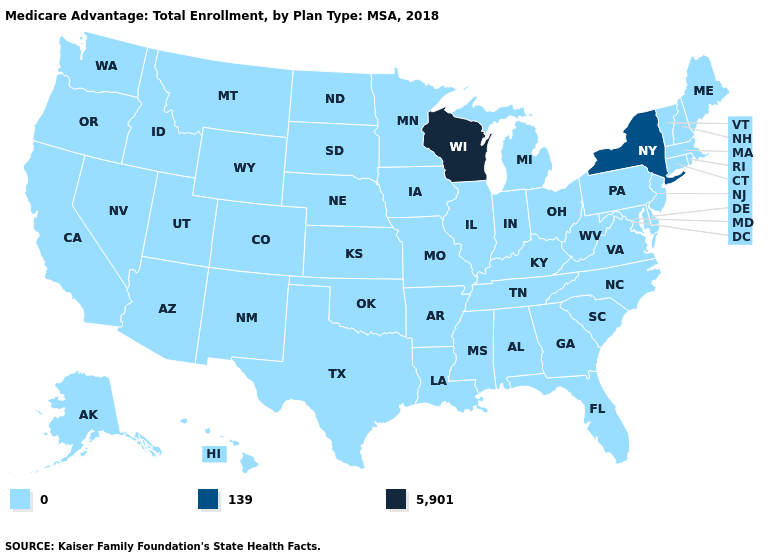What is the value of South Dakota?
Short answer required. 0. Which states hav the highest value in the South?
Give a very brief answer. Alabama, Arkansas, Delaware, Florida, Georgia, Kentucky, Louisiana, Maryland, Mississippi, North Carolina, Oklahoma, South Carolina, Tennessee, Texas, Virginia, West Virginia. What is the lowest value in the Northeast?
Answer briefly. 0. What is the lowest value in the USA?
Be succinct. 0. What is the value of Delaware?
Quick response, please. 0. Which states have the highest value in the USA?
Give a very brief answer. Wisconsin. Name the states that have a value in the range 0?
Short answer required. Alabama, Alaska, Arizona, Arkansas, California, Colorado, Connecticut, Delaware, Florida, Georgia, Hawaii, Idaho, Illinois, Indiana, Iowa, Kansas, Kentucky, Louisiana, Maine, Maryland, Massachusetts, Michigan, Minnesota, Mississippi, Missouri, Montana, Nebraska, Nevada, New Hampshire, New Jersey, New Mexico, North Carolina, North Dakota, Ohio, Oklahoma, Oregon, Pennsylvania, Rhode Island, South Carolina, South Dakota, Tennessee, Texas, Utah, Vermont, Virginia, Washington, West Virginia, Wyoming. How many symbols are there in the legend?
Be succinct. 3. What is the highest value in the West ?
Write a very short answer. 0. Among the states that border North Dakota , which have the highest value?
Give a very brief answer. Minnesota, Montana, South Dakota. Name the states that have a value in the range 0?
Quick response, please. Alabama, Alaska, Arizona, Arkansas, California, Colorado, Connecticut, Delaware, Florida, Georgia, Hawaii, Idaho, Illinois, Indiana, Iowa, Kansas, Kentucky, Louisiana, Maine, Maryland, Massachusetts, Michigan, Minnesota, Mississippi, Missouri, Montana, Nebraska, Nevada, New Hampshire, New Jersey, New Mexico, North Carolina, North Dakota, Ohio, Oklahoma, Oregon, Pennsylvania, Rhode Island, South Carolina, South Dakota, Tennessee, Texas, Utah, Vermont, Virginia, Washington, West Virginia, Wyoming. Name the states that have a value in the range 0?
Be succinct. Alabama, Alaska, Arizona, Arkansas, California, Colorado, Connecticut, Delaware, Florida, Georgia, Hawaii, Idaho, Illinois, Indiana, Iowa, Kansas, Kentucky, Louisiana, Maine, Maryland, Massachusetts, Michigan, Minnesota, Mississippi, Missouri, Montana, Nebraska, Nevada, New Hampshire, New Jersey, New Mexico, North Carolina, North Dakota, Ohio, Oklahoma, Oregon, Pennsylvania, Rhode Island, South Carolina, South Dakota, Tennessee, Texas, Utah, Vermont, Virginia, Washington, West Virginia, Wyoming. What is the value of Maryland?
Concise answer only. 0. 